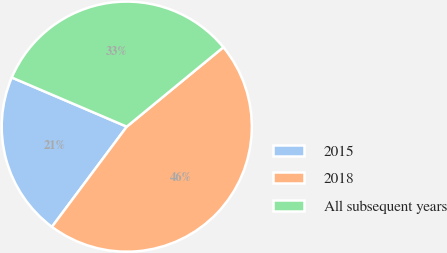Convert chart to OTSL. <chart><loc_0><loc_0><loc_500><loc_500><pie_chart><fcel>2015<fcel>2018<fcel>All subsequent years<nl><fcel>21.22%<fcel>46.16%<fcel>32.62%<nl></chart> 